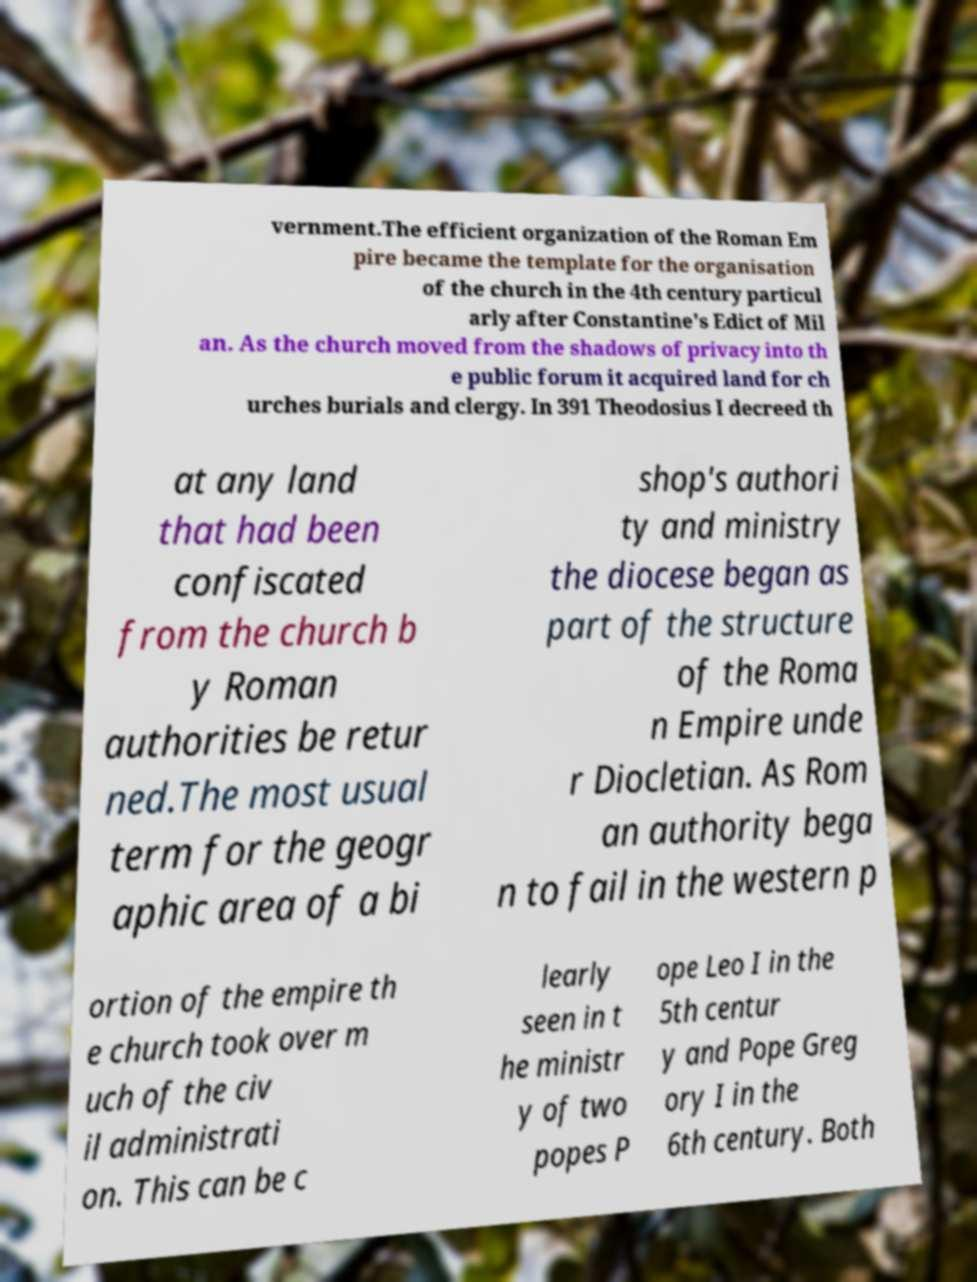Can you accurately transcribe the text from the provided image for me? vernment.The efficient organization of the Roman Em pire became the template for the organisation of the church in the 4th century particul arly after Constantine's Edict of Mil an. As the church moved from the shadows of privacy into th e public forum it acquired land for ch urches burials and clergy. In 391 Theodosius I decreed th at any land that had been confiscated from the church b y Roman authorities be retur ned.The most usual term for the geogr aphic area of a bi shop's authori ty and ministry the diocese began as part of the structure of the Roma n Empire unde r Diocletian. As Rom an authority bega n to fail in the western p ortion of the empire th e church took over m uch of the civ il administrati on. This can be c learly seen in t he ministr y of two popes P ope Leo I in the 5th centur y and Pope Greg ory I in the 6th century. Both 